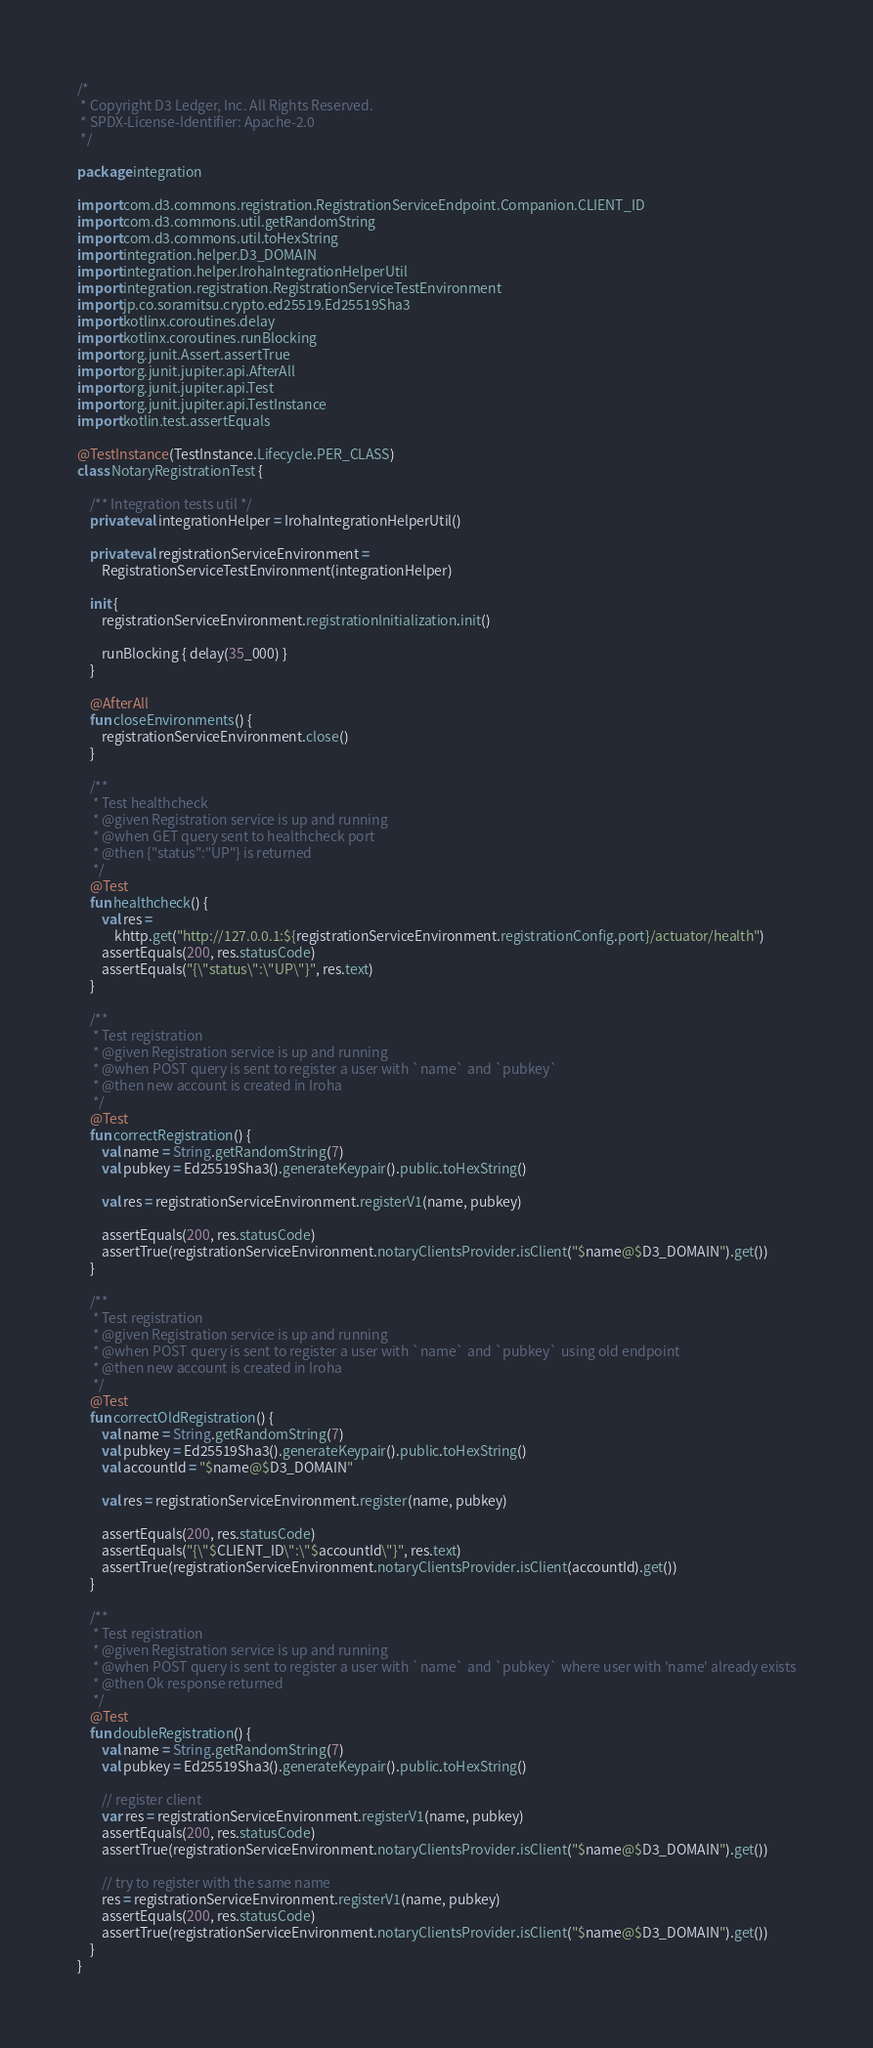Convert code to text. <code><loc_0><loc_0><loc_500><loc_500><_Kotlin_>/*
 * Copyright D3 Ledger, Inc. All Rights Reserved.
 * SPDX-License-Identifier: Apache-2.0
 */

package integration

import com.d3.commons.registration.RegistrationServiceEndpoint.Companion.CLIENT_ID
import com.d3.commons.util.getRandomString
import com.d3.commons.util.toHexString
import integration.helper.D3_DOMAIN
import integration.helper.IrohaIntegrationHelperUtil
import integration.registration.RegistrationServiceTestEnvironment
import jp.co.soramitsu.crypto.ed25519.Ed25519Sha3
import kotlinx.coroutines.delay
import kotlinx.coroutines.runBlocking
import org.junit.Assert.assertTrue
import org.junit.jupiter.api.AfterAll
import org.junit.jupiter.api.Test
import org.junit.jupiter.api.TestInstance
import kotlin.test.assertEquals

@TestInstance(TestInstance.Lifecycle.PER_CLASS)
class NotaryRegistrationTest {

    /** Integration tests util */
    private val integrationHelper = IrohaIntegrationHelperUtil()

    private val registrationServiceEnvironment =
        RegistrationServiceTestEnvironment(integrationHelper)

    init {
        registrationServiceEnvironment.registrationInitialization.init()

        runBlocking { delay(35_000) }
    }

    @AfterAll
    fun closeEnvironments() {
        registrationServiceEnvironment.close()
    }

    /**
     * Test healthcheck
     * @given Registration service is up and running
     * @when GET query sent to healthcheck port
     * @then {"status":"UP"} is returned
     */
    @Test
    fun healthcheck() {
        val res =
            khttp.get("http://127.0.0.1:${registrationServiceEnvironment.registrationConfig.port}/actuator/health")
        assertEquals(200, res.statusCode)
        assertEquals("{\"status\":\"UP\"}", res.text)
    }

    /**
     * Test registration
     * @given Registration service is up and running
     * @when POST query is sent to register a user with `name` and `pubkey`
     * @then new account is created in Iroha
     */
    @Test
    fun correctRegistration() {
        val name = String.getRandomString(7)
        val pubkey = Ed25519Sha3().generateKeypair().public.toHexString()

        val res = registrationServiceEnvironment.registerV1(name, pubkey)

        assertEquals(200, res.statusCode)
        assertTrue(registrationServiceEnvironment.notaryClientsProvider.isClient("$name@$D3_DOMAIN").get())
    }

    /**
     * Test registration
     * @given Registration service is up and running
     * @when POST query is sent to register a user with `name` and `pubkey` using old endpoint
     * @then new account is created in Iroha
     */
    @Test
    fun correctOldRegistration() {
        val name = String.getRandomString(7)
        val pubkey = Ed25519Sha3().generateKeypair().public.toHexString()
        val accountId = "$name@$D3_DOMAIN"

        val res = registrationServiceEnvironment.register(name, pubkey)

        assertEquals(200, res.statusCode)
        assertEquals("{\"$CLIENT_ID\":\"$accountId\"}", res.text)
        assertTrue(registrationServiceEnvironment.notaryClientsProvider.isClient(accountId).get())
    }

    /**
     * Test registration
     * @given Registration service is up and running
     * @when POST query is sent to register a user with `name` and `pubkey` where user with 'name' already exists
     * @then Ok response returned
     */
    @Test
    fun doubleRegistration() {
        val name = String.getRandomString(7)
        val pubkey = Ed25519Sha3().generateKeypair().public.toHexString()

        // register client
        var res = registrationServiceEnvironment.registerV1(name, pubkey)
        assertEquals(200, res.statusCode)
        assertTrue(registrationServiceEnvironment.notaryClientsProvider.isClient("$name@$D3_DOMAIN").get())

        // try to register with the same name
        res = registrationServiceEnvironment.registerV1(name, pubkey)
        assertEquals(200, res.statusCode)
        assertTrue(registrationServiceEnvironment.notaryClientsProvider.isClient("$name@$D3_DOMAIN").get())
    }
}
</code> 